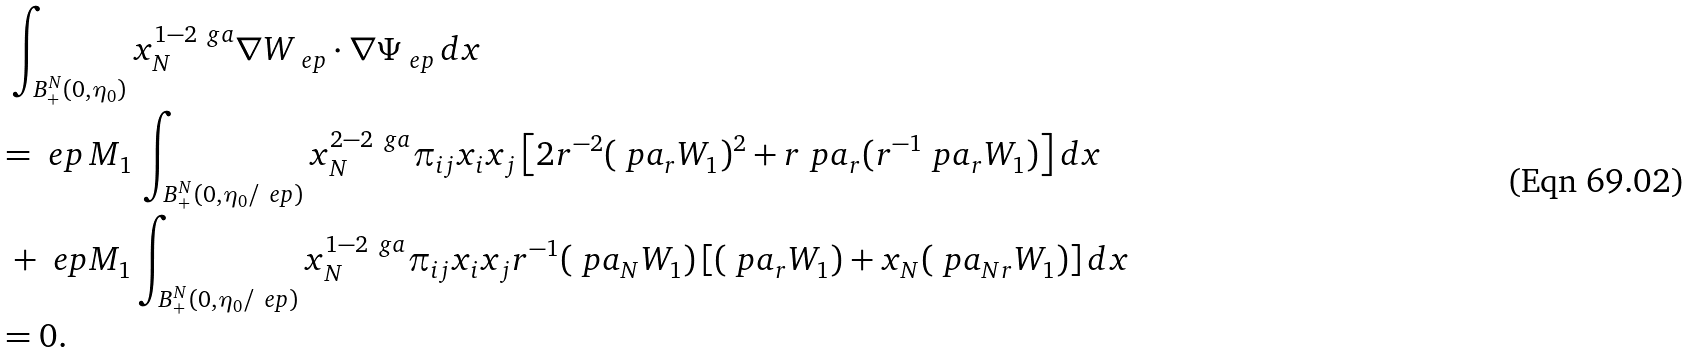<formula> <loc_0><loc_0><loc_500><loc_500>& \ \int _ { B ^ { N } _ { + } ( 0 , \eta _ { 0 } ) } x _ { N } ^ { 1 - 2 \ g a } \nabla W _ { \ e p } \cdot \nabla \Psi _ { \ e p } \, d x \\ & = \ e p \, M _ { 1 } \, \int _ { B ^ { N } _ { + } ( 0 , \eta _ { 0 } / \ e p ) } x _ { N } ^ { 2 - 2 \ g a } \pi _ { i j } x _ { i } x _ { j } \left [ 2 r ^ { - 2 } ( \ p a _ { r } W _ { 1 } ) ^ { 2 } + r \ p a _ { r } ( r ^ { - 1 } \ p a _ { r } W _ { 1 } ) \right ] d x \\ & \ + \ e p M _ { 1 } \int _ { B ^ { N } _ { + } ( 0 , \eta _ { 0 } / \ e p ) } x _ { N } ^ { 1 - 2 \ g a } \pi _ { i j } x _ { i } x _ { j } r ^ { - 1 } ( \ p a _ { N } W _ { 1 } ) \left [ ( \ p a _ { r } W _ { 1 } ) + x _ { N } ( \ p a _ { N r } W _ { 1 } ) \right ] d x \\ & = 0 .</formula> 